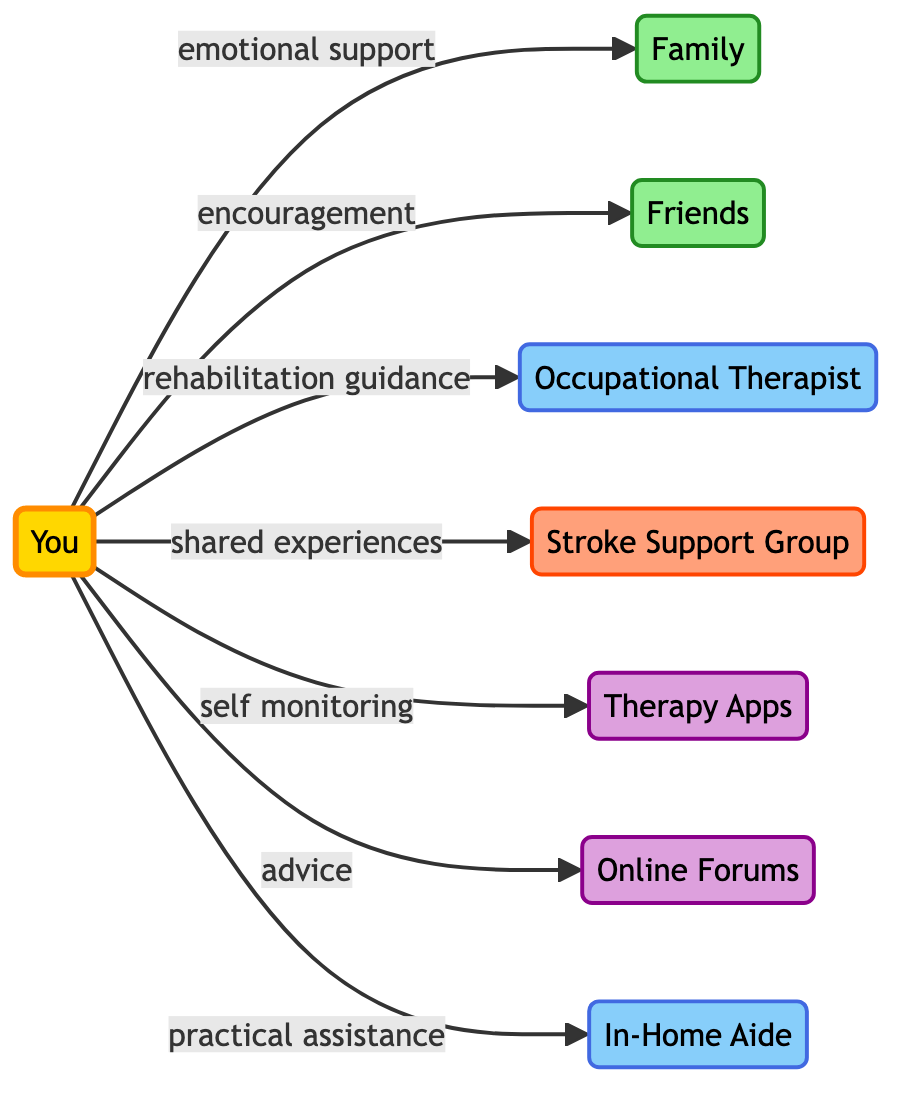What's the total number of nodes in the diagram? To find the total number of nodes, we count each unique item listed under the "nodes" section. There are eight nodes: You, Family, Friends, Occupational Therapist, Stroke Support Group, Therapy Apps, Online Forums, and In-Home Aide.
Answer: 8 What type of support is received from Family? By looking at the edge connecting "You" to "Family," it is labeled as "emotionalSupport." Therefore, the type of support received is defined as emotional support.
Answer: emotional support Which professional is linked for rehabilitation guidance? The edge that connects "You" to a professional indicates which one provides rehabilitation guidance. The corresponding node is "Occupational Therapist," making it the linked professional.
Answer: Occupational Therapist How many types of digital resources are mentioned in the diagram? By inspecting the "nodes" section, we see two entries categorized as digital resources: "Therapy Apps" and "Online Forums." Thus, we count these to find the total.
Answer: 2 What is the relationship between "You" and "Support Group"? The diagram shows a directed edge from "You" to "Support Group," labeled as "sharedExperiences." This indicates support associated with shared experiences is derived from the support group.
Answer: shared experiences What type of assistance does the In-Home Aide provide? The edge leading from "You" to "In-Home Aide" is labeled "practicalAssistance." Therefore, the type of assistance provided by an In-Home Aide can be identified directly from this label.
Answer: practical assistance Which digital resource is used for self-monitoring? In examining the connection from "You" to the corresponding digital resource, "Therapy Apps," the label indicates the functionality, which is self-monitoring.
Answer: Therapy Apps What connects the relationships between "You" and "Friends"? The edge connects "You" to "Friends," and it's labeled "encouragement." This relationship indicates the support dynamic present with friends in terms of encouragement.
Answer: encouragement Who benefits from shared experiences? The directed edge clearly shows that the "Support Group" node is linked with the "You" node, indicating that "You" benefit from shared experiences with the support group.
Answer: You 